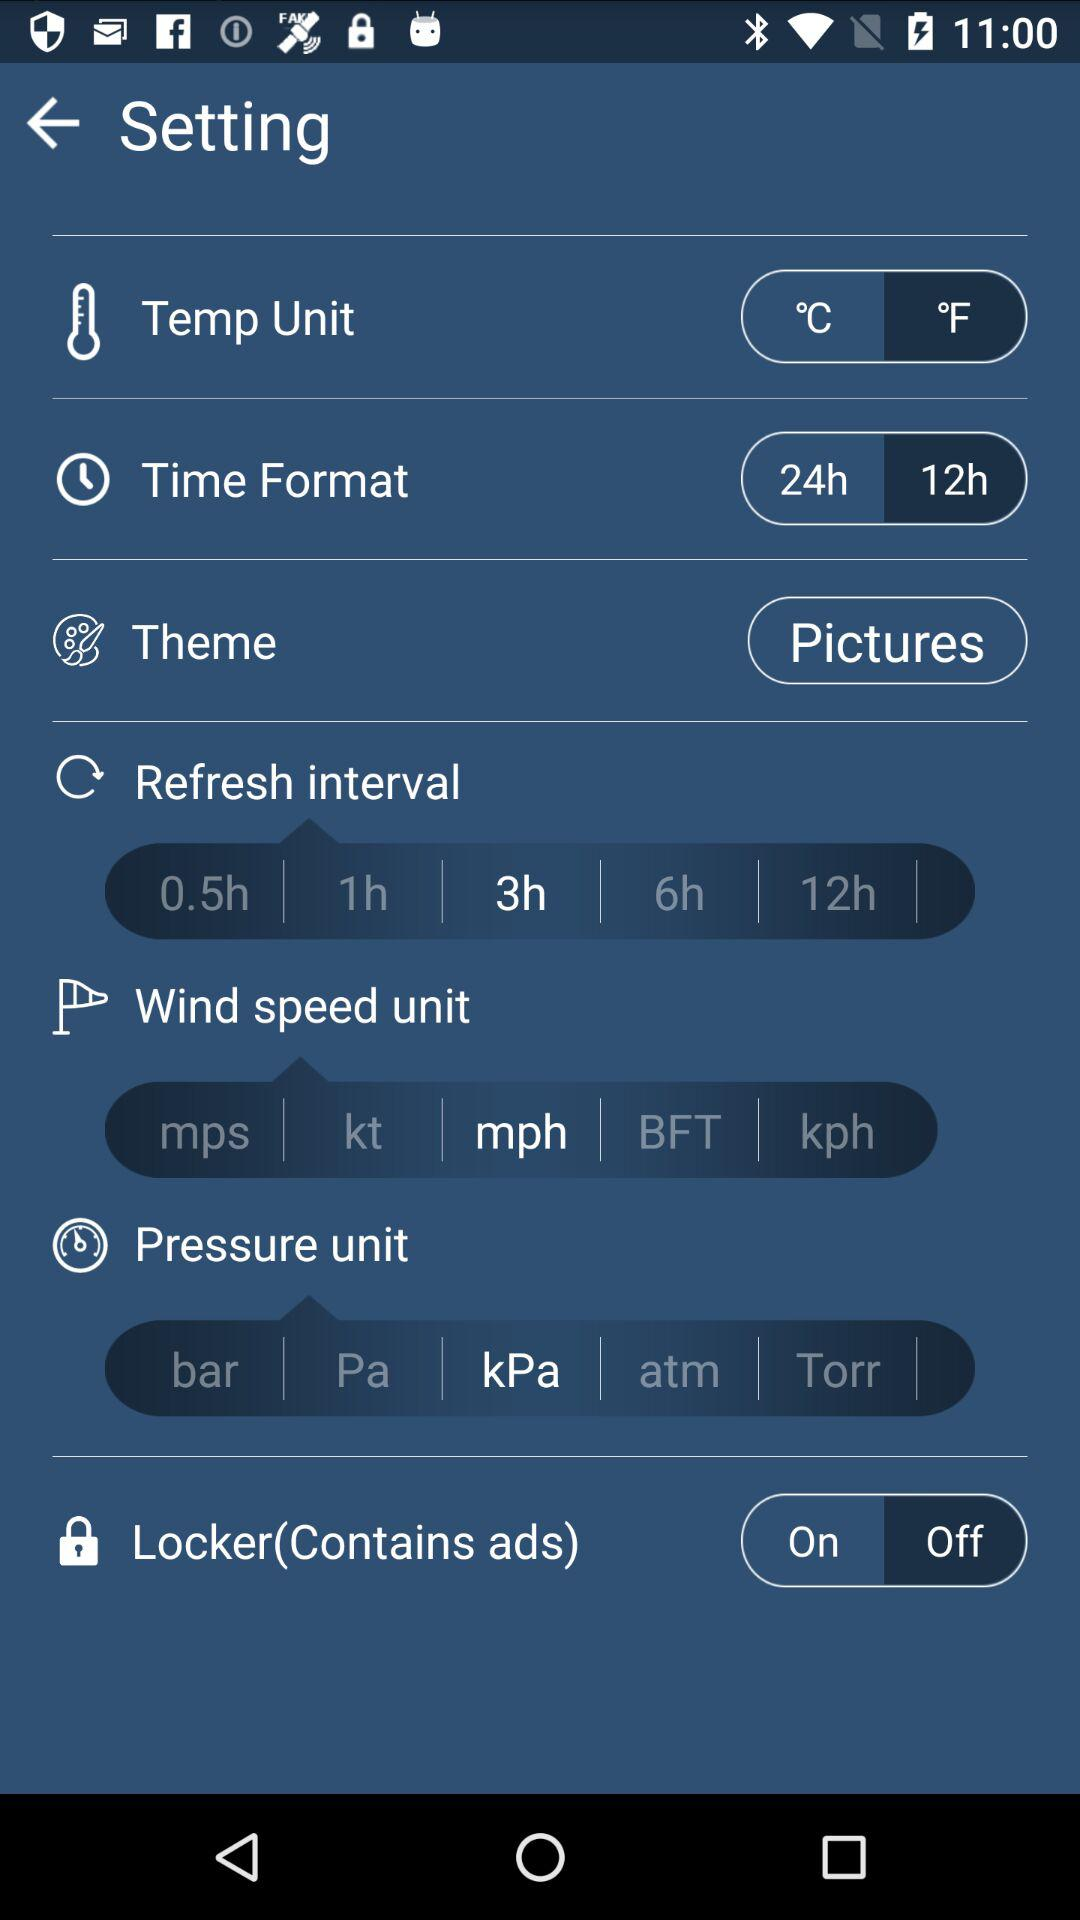Which wind speed unit is selected? The selected speed unit is mph. 